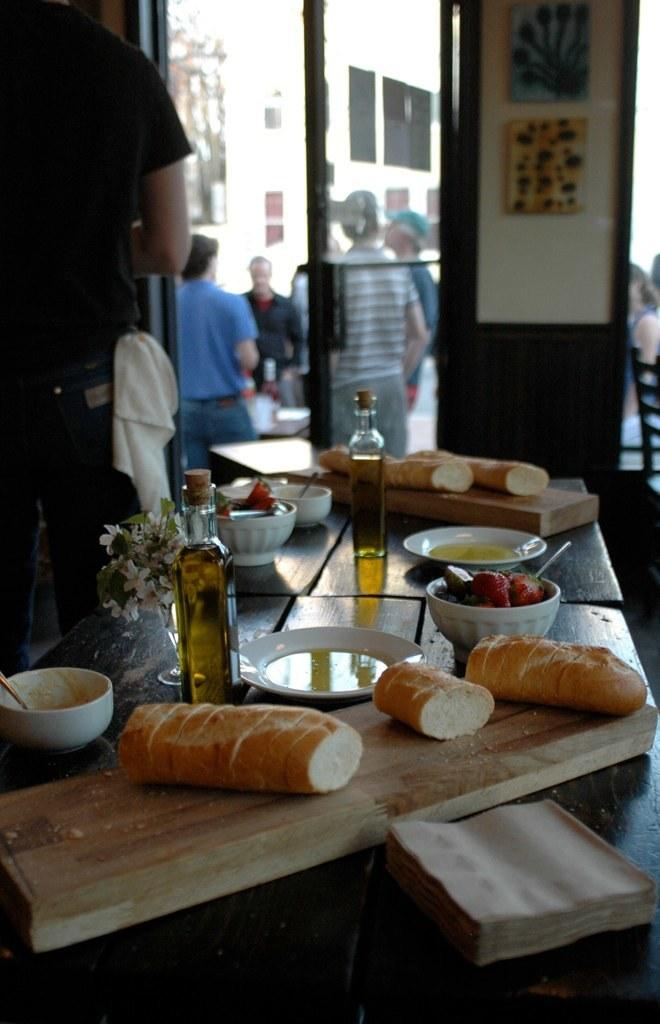What is on the floor in the image? There is a table on the floor in the image. What is on the table? There are food items on the table in the image. Are there any people in the image? Yes, there are people standing in the image. What architectural feature can be seen in the image? There is a door in the image. Where is the stage located in the image? There is no stage present in the image. Is there a rifle visible in the image? No, there is no rifle present in the image. 